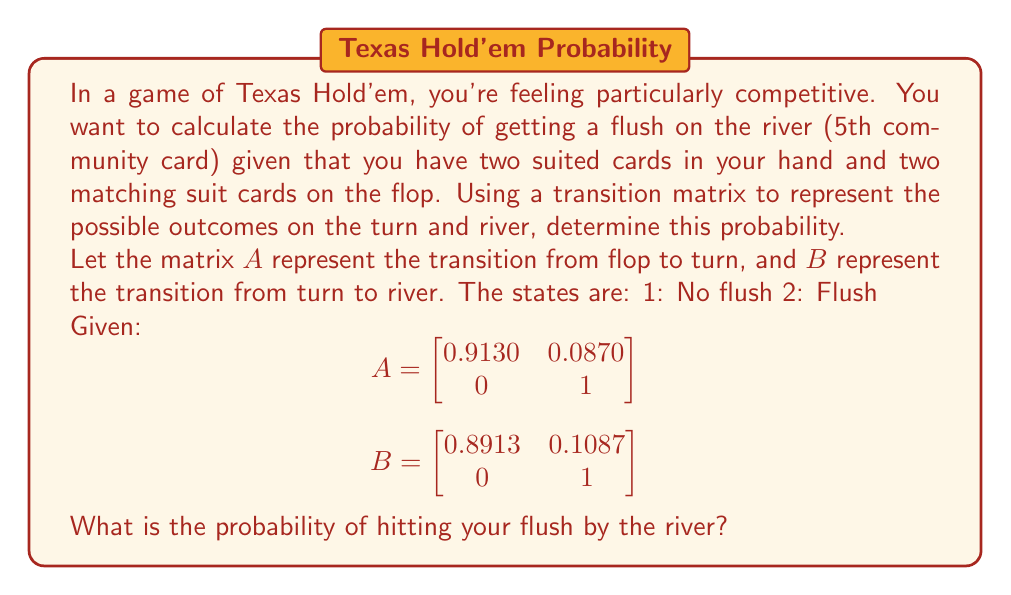Show me your answer to this math problem. To solve this problem, we'll use matrix multiplication to determine the final probability distribution after both the turn and river cards are dealt.

Step 1: Initial state vector
Since we start with no flush after the flop, our initial state vector is:
$v_0 = \begin{bmatrix} 1 \\ 0 \end{bmatrix}$

Step 2: Calculate the state after the turn
$v_1 = Av_0 = \begin{bmatrix}
0.9130 & 0.0870 \\
0 & 1
\end{bmatrix} \begin{bmatrix} 1 \\ 0 \end{bmatrix} = \begin{bmatrix} 0.9130 \\ 0.0870 \end{bmatrix}$

Step 3: Calculate the final state after the river
$v_2 = Bv_1 = \begin{bmatrix}
0.8913 & 0.1087 \\
0 & 1
\end{bmatrix} \begin{bmatrix} 0.9130 \\ 0.0870 \end{bmatrix}$

$v_2 = \begin{bmatrix}
(0.8913 \times 0.9130) + (0.1087 \times 0.0870) \\
(0 \times 0.9130) + (1 \times 0.0870)
\end{bmatrix}$

$v_2 = \begin{bmatrix}
0.8137 + 0.0095 \\
0.0870
\end{bmatrix} = \begin{bmatrix}
0.8232 \\
0.1768
\end{bmatrix}$

Step 4: Interpret the result
The second element of the final state vector $v_2$ represents the probability of having a flush by the river. Therefore, the probability of hitting your flush by the river is 0.1768 or 17.68%.
Answer: 0.1768 